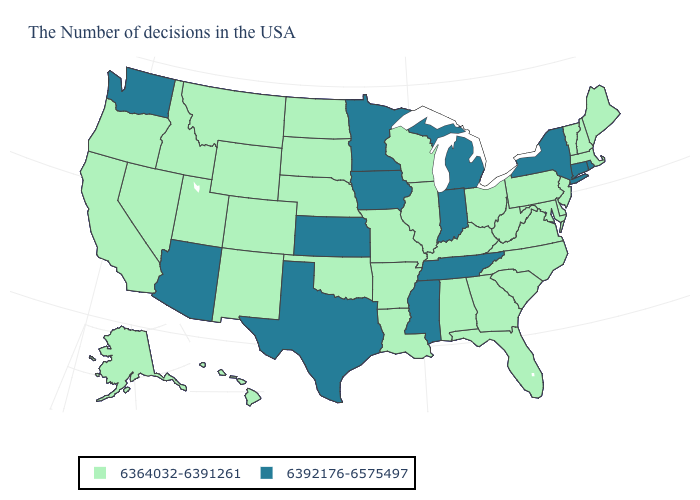Does Wyoming have the same value as Illinois?
Give a very brief answer. Yes. What is the value of Minnesota?
Write a very short answer. 6392176-6575497. Is the legend a continuous bar?
Write a very short answer. No. What is the lowest value in states that border California?
Give a very brief answer. 6364032-6391261. Name the states that have a value in the range 6392176-6575497?
Give a very brief answer. Rhode Island, Connecticut, New York, Michigan, Indiana, Tennessee, Mississippi, Minnesota, Iowa, Kansas, Texas, Arizona, Washington. What is the lowest value in the Northeast?
Keep it brief. 6364032-6391261. Name the states that have a value in the range 6392176-6575497?
Quick response, please. Rhode Island, Connecticut, New York, Michigan, Indiana, Tennessee, Mississippi, Minnesota, Iowa, Kansas, Texas, Arizona, Washington. Does Indiana have the highest value in the MidWest?
Give a very brief answer. Yes. Name the states that have a value in the range 6392176-6575497?
Write a very short answer. Rhode Island, Connecticut, New York, Michigan, Indiana, Tennessee, Mississippi, Minnesota, Iowa, Kansas, Texas, Arizona, Washington. Name the states that have a value in the range 6392176-6575497?
Concise answer only. Rhode Island, Connecticut, New York, Michigan, Indiana, Tennessee, Mississippi, Minnesota, Iowa, Kansas, Texas, Arizona, Washington. Among the states that border Louisiana , which have the highest value?
Give a very brief answer. Mississippi, Texas. Name the states that have a value in the range 6364032-6391261?
Write a very short answer. Maine, Massachusetts, New Hampshire, Vermont, New Jersey, Delaware, Maryland, Pennsylvania, Virginia, North Carolina, South Carolina, West Virginia, Ohio, Florida, Georgia, Kentucky, Alabama, Wisconsin, Illinois, Louisiana, Missouri, Arkansas, Nebraska, Oklahoma, South Dakota, North Dakota, Wyoming, Colorado, New Mexico, Utah, Montana, Idaho, Nevada, California, Oregon, Alaska, Hawaii. Does Virginia have the lowest value in the South?
Write a very short answer. Yes. Among the states that border Michigan , does Indiana have the highest value?
Give a very brief answer. Yes. Among the states that border California , which have the highest value?
Answer briefly. Arizona. 